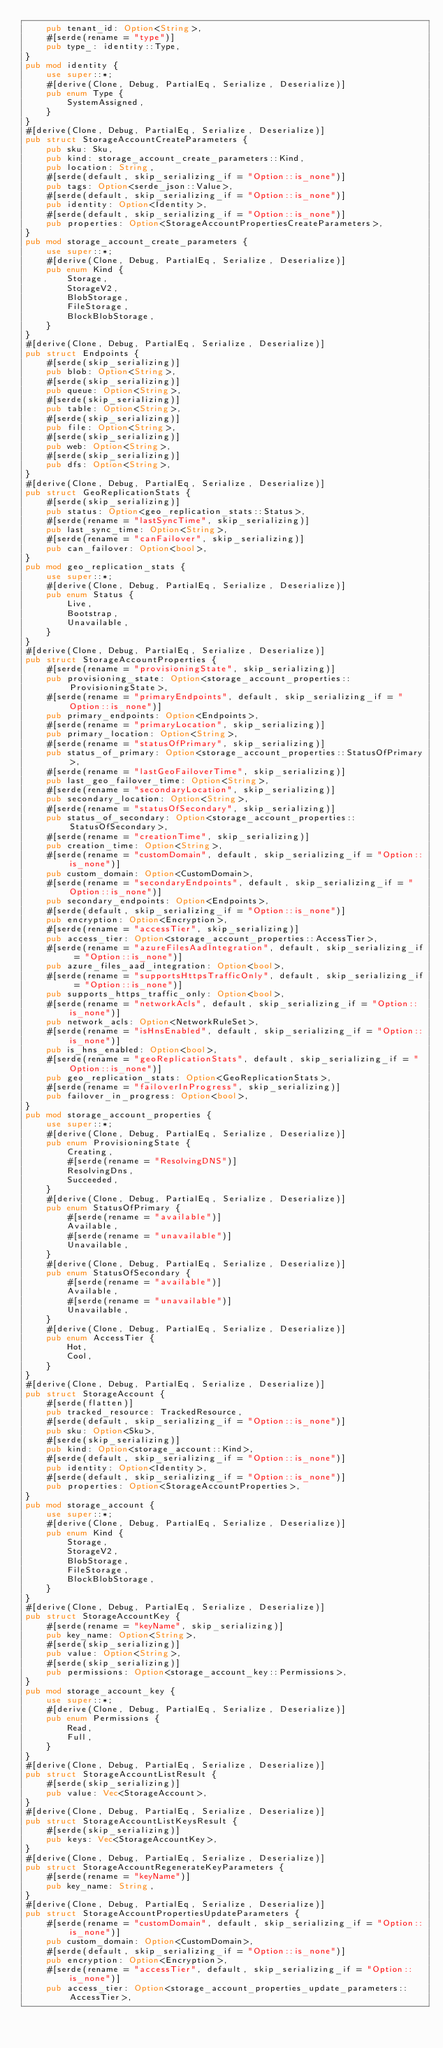Convert code to text. <code><loc_0><loc_0><loc_500><loc_500><_Rust_>    pub tenant_id: Option<String>,
    #[serde(rename = "type")]
    pub type_: identity::Type,
}
pub mod identity {
    use super::*;
    #[derive(Clone, Debug, PartialEq, Serialize, Deserialize)]
    pub enum Type {
        SystemAssigned,
    }
}
#[derive(Clone, Debug, PartialEq, Serialize, Deserialize)]
pub struct StorageAccountCreateParameters {
    pub sku: Sku,
    pub kind: storage_account_create_parameters::Kind,
    pub location: String,
    #[serde(default, skip_serializing_if = "Option::is_none")]
    pub tags: Option<serde_json::Value>,
    #[serde(default, skip_serializing_if = "Option::is_none")]
    pub identity: Option<Identity>,
    #[serde(default, skip_serializing_if = "Option::is_none")]
    pub properties: Option<StorageAccountPropertiesCreateParameters>,
}
pub mod storage_account_create_parameters {
    use super::*;
    #[derive(Clone, Debug, PartialEq, Serialize, Deserialize)]
    pub enum Kind {
        Storage,
        StorageV2,
        BlobStorage,
        FileStorage,
        BlockBlobStorage,
    }
}
#[derive(Clone, Debug, PartialEq, Serialize, Deserialize)]
pub struct Endpoints {
    #[serde(skip_serializing)]
    pub blob: Option<String>,
    #[serde(skip_serializing)]
    pub queue: Option<String>,
    #[serde(skip_serializing)]
    pub table: Option<String>,
    #[serde(skip_serializing)]
    pub file: Option<String>,
    #[serde(skip_serializing)]
    pub web: Option<String>,
    #[serde(skip_serializing)]
    pub dfs: Option<String>,
}
#[derive(Clone, Debug, PartialEq, Serialize, Deserialize)]
pub struct GeoReplicationStats {
    #[serde(skip_serializing)]
    pub status: Option<geo_replication_stats::Status>,
    #[serde(rename = "lastSyncTime", skip_serializing)]
    pub last_sync_time: Option<String>,
    #[serde(rename = "canFailover", skip_serializing)]
    pub can_failover: Option<bool>,
}
pub mod geo_replication_stats {
    use super::*;
    #[derive(Clone, Debug, PartialEq, Serialize, Deserialize)]
    pub enum Status {
        Live,
        Bootstrap,
        Unavailable,
    }
}
#[derive(Clone, Debug, PartialEq, Serialize, Deserialize)]
pub struct StorageAccountProperties {
    #[serde(rename = "provisioningState", skip_serializing)]
    pub provisioning_state: Option<storage_account_properties::ProvisioningState>,
    #[serde(rename = "primaryEndpoints", default, skip_serializing_if = "Option::is_none")]
    pub primary_endpoints: Option<Endpoints>,
    #[serde(rename = "primaryLocation", skip_serializing)]
    pub primary_location: Option<String>,
    #[serde(rename = "statusOfPrimary", skip_serializing)]
    pub status_of_primary: Option<storage_account_properties::StatusOfPrimary>,
    #[serde(rename = "lastGeoFailoverTime", skip_serializing)]
    pub last_geo_failover_time: Option<String>,
    #[serde(rename = "secondaryLocation", skip_serializing)]
    pub secondary_location: Option<String>,
    #[serde(rename = "statusOfSecondary", skip_serializing)]
    pub status_of_secondary: Option<storage_account_properties::StatusOfSecondary>,
    #[serde(rename = "creationTime", skip_serializing)]
    pub creation_time: Option<String>,
    #[serde(rename = "customDomain", default, skip_serializing_if = "Option::is_none")]
    pub custom_domain: Option<CustomDomain>,
    #[serde(rename = "secondaryEndpoints", default, skip_serializing_if = "Option::is_none")]
    pub secondary_endpoints: Option<Endpoints>,
    #[serde(default, skip_serializing_if = "Option::is_none")]
    pub encryption: Option<Encryption>,
    #[serde(rename = "accessTier", skip_serializing)]
    pub access_tier: Option<storage_account_properties::AccessTier>,
    #[serde(rename = "azureFilesAadIntegration", default, skip_serializing_if = "Option::is_none")]
    pub azure_files_aad_integration: Option<bool>,
    #[serde(rename = "supportsHttpsTrafficOnly", default, skip_serializing_if = "Option::is_none")]
    pub supports_https_traffic_only: Option<bool>,
    #[serde(rename = "networkAcls", default, skip_serializing_if = "Option::is_none")]
    pub network_acls: Option<NetworkRuleSet>,
    #[serde(rename = "isHnsEnabled", default, skip_serializing_if = "Option::is_none")]
    pub is_hns_enabled: Option<bool>,
    #[serde(rename = "geoReplicationStats", default, skip_serializing_if = "Option::is_none")]
    pub geo_replication_stats: Option<GeoReplicationStats>,
    #[serde(rename = "failoverInProgress", skip_serializing)]
    pub failover_in_progress: Option<bool>,
}
pub mod storage_account_properties {
    use super::*;
    #[derive(Clone, Debug, PartialEq, Serialize, Deserialize)]
    pub enum ProvisioningState {
        Creating,
        #[serde(rename = "ResolvingDNS")]
        ResolvingDns,
        Succeeded,
    }
    #[derive(Clone, Debug, PartialEq, Serialize, Deserialize)]
    pub enum StatusOfPrimary {
        #[serde(rename = "available")]
        Available,
        #[serde(rename = "unavailable")]
        Unavailable,
    }
    #[derive(Clone, Debug, PartialEq, Serialize, Deserialize)]
    pub enum StatusOfSecondary {
        #[serde(rename = "available")]
        Available,
        #[serde(rename = "unavailable")]
        Unavailable,
    }
    #[derive(Clone, Debug, PartialEq, Serialize, Deserialize)]
    pub enum AccessTier {
        Hot,
        Cool,
    }
}
#[derive(Clone, Debug, PartialEq, Serialize, Deserialize)]
pub struct StorageAccount {
    #[serde(flatten)]
    pub tracked_resource: TrackedResource,
    #[serde(default, skip_serializing_if = "Option::is_none")]
    pub sku: Option<Sku>,
    #[serde(skip_serializing)]
    pub kind: Option<storage_account::Kind>,
    #[serde(default, skip_serializing_if = "Option::is_none")]
    pub identity: Option<Identity>,
    #[serde(default, skip_serializing_if = "Option::is_none")]
    pub properties: Option<StorageAccountProperties>,
}
pub mod storage_account {
    use super::*;
    #[derive(Clone, Debug, PartialEq, Serialize, Deserialize)]
    pub enum Kind {
        Storage,
        StorageV2,
        BlobStorage,
        FileStorage,
        BlockBlobStorage,
    }
}
#[derive(Clone, Debug, PartialEq, Serialize, Deserialize)]
pub struct StorageAccountKey {
    #[serde(rename = "keyName", skip_serializing)]
    pub key_name: Option<String>,
    #[serde(skip_serializing)]
    pub value: Option<String>,
    #[serde(skip_serializing)]
    pub permissions: Option<storage_account_key::Permissions>,
}
pub mod storage_account_key {
    use super::*;
    #[derive(Clone, Debug, PartialEq, Serialize, Deserialize)]
    pub enum Permissions {
        Read,
        Full,
    }
}
#[derive(Clone, Debug, PartialEq, Serialize, Deserialize)]
pub struct StorageAccountListResult {
    #[serde(skip_serializing)]
    pub value: Vec<StorageAccount>,
}
#[derive(Clone, Debug, PartialEq, Serialize, Deserialize)]
pub struct StorageAccountListKeysResult {
    #[serde(skip_serializing)]
    pub keys: Vec<StorageAccountKey>,
}
#[derive(Clone, Debug, PartialEq, Serialize, Deserialize)]
pub struct StorageAccountRegenerateKeyParameters {
    #[serde(rename = "keyName")]
    pub key_name: String,
}
#[derive(Clone, Debug, PartialEq, Serialize, Deserialize)]
pub struct StorageAccountPropertiesUpdateParameters {
    #[serde(rename = "customDomain", default, skip_serializing_if = "Option::is_none")]
    pub custom_domain: Option<CustomDomain>,
    #[serde(default, skip_serializing_if = "Option::is_none")]
    pub encryption: Option<Encryption>,
    #[serde(rename = "accessTier", default, skip_serializing_if = "Option::is_none")]
    pub access_tier: Option<storage_account_properties_update_parameters::AccessTier>,</code> 